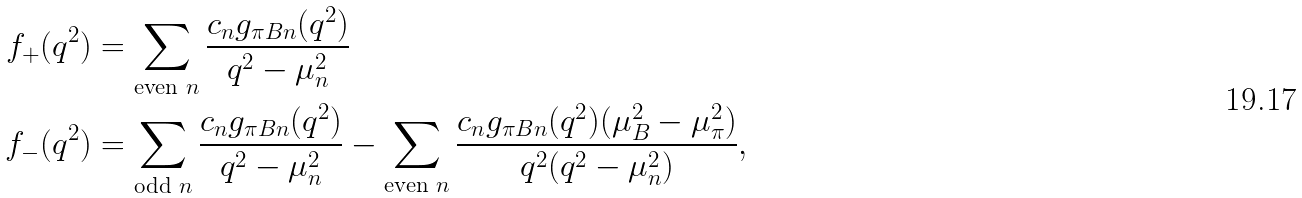Convert formula to latex. <formula><loc_0><loc_0><loc_500><loc_500>f _ { + } ( q ^ { 2 } ) & = \sum _ { \text {even $n$} } \frac { c _ { n } g _ { \pi B n } ( q ^ { 2 } ) } { q ^ { 2 } - \mu _ { n } ^ { 2 } } \\ f _ { - } ( q ^ { 2 } ) & = \sum _ { \text {odd $n$} } \frac { c _ { n } g _ { \pi B n } ( q ^ { 2 } ) } { q ^ { 2 } - \mu _ { n } ^ { 2 } } - \sum _ { \text {even $n$} } \frac { c _ { n } g _ { \pi B n } ( q ^ { 2 } ) ( \mu _ { B } ^ { 2 } - \mu _ { \pi } ^ { 2 } ) } { q ^ { 2 } ( q ^ { 2 } - \mu _ { n } ^ { 2 } ) } ,</formula> 